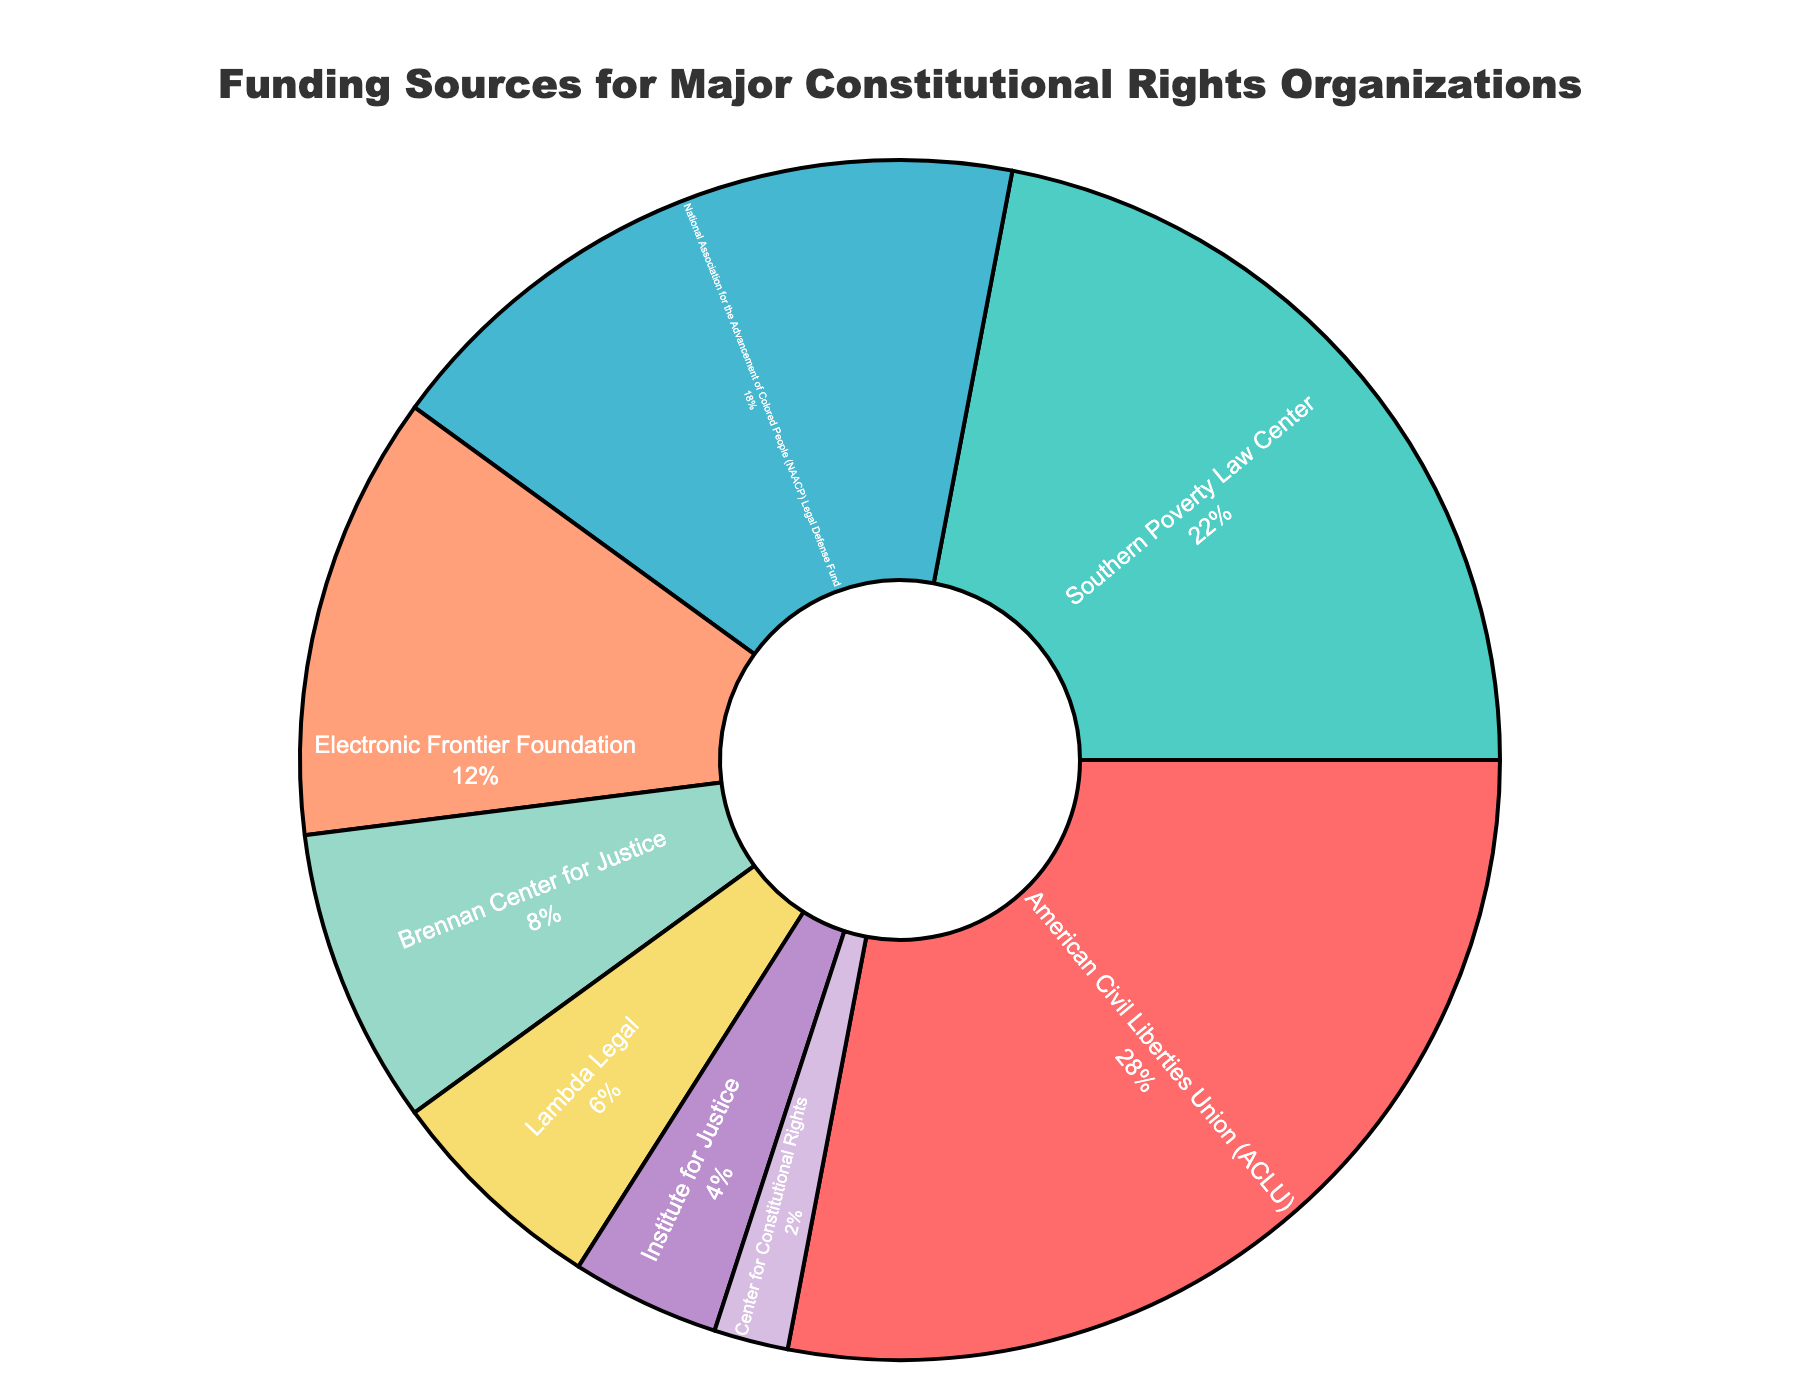which organization receives the highest percentage of funding? The chart shows different organizations with their corresponding funding percentages inside the pie slices. The slice for the American Civil Liberties Union (ACLU) has the highest value of 28%.
Answer: ACLU what is the sum of the funding percentages for the NAACP Legal Defense Fund and the Brennan Center for Justice? The NAACP Legal Defense Fund's percentage is 18% and the Brennan Center for Justice's percentage is 8%. Adding these together: 18% + 8% = 26%.
Answer: 26% which organization receives more funding: Lambda Legal or the Electronic Frontier Foundation? The Electronic Frontier Foundation has a funding percentage of 12%, while Lambda Legal has 6%. Since 12% > 6%, the Electronic Frontier Foundation receives more funding.
Answer: Electronic Frontier Foundation how much more funding does the ACLU receive compared to the Southern Poverty Law Center? The ACLU has 28% funding and the Southern Poverty Law Center has 22%. Subtracting these: 28% - 22% = 6%.
Answer: 6% what is the combined percentage of funding for the bottom three organizations? The bottom three organizations are the Center for Constitutional Rights (2%), Institute for Justice (4%), and Lambda Legal (6%). Adding these values: 2% + 4% + 6% = 12%.
Answer: 12% which organization's funding percentage is closest to the average percentage of all organizations? To find the average, sum all the percentages: 28% + 22% + 18% + 12% + 8% + 6% + 4% + 2% = 100%. The average is 100% / 8 = 12.5%. The Electronic Frontier Foundation at 12% is closest to this average.
Answer: Electronic Frontier Foundation what is the difference in funding percentage between the National Association for the Advancement of Colored People (NAACP) Legal Defense Fund and the Brennan Center for Justice? The NAACP Legal Defense Fund's percentage is 18% and the Brennan Center for Justice's is 8%. The difference is 18% - 8% = 10%.
Answer: 10% which organization has a funding percentage represented by a green slice? The slices of the pie chart are assigned specific colors, and the Southern Poverty Law Center's slice is colored green. Thus, the funding percentage represented by a green slice corresponds to the Southern Poverty Law Center.
Answer: Southern Poverty Law Center 